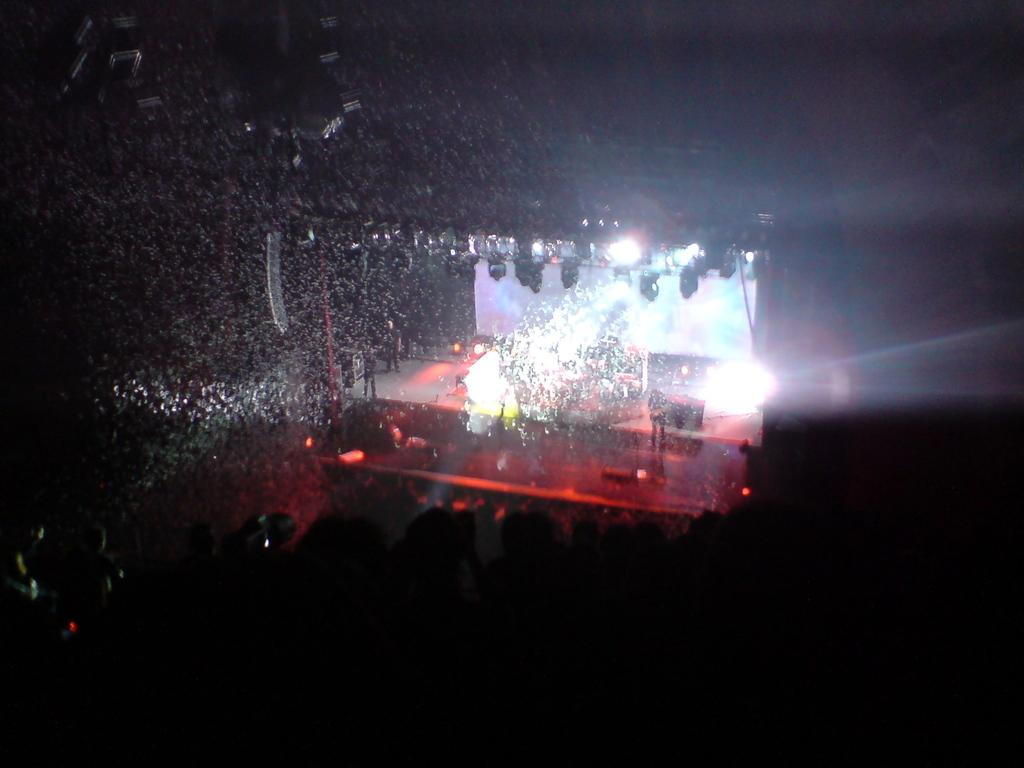What is the main feature in the center of the image? There is a stage in the center of the image. What can be seen illuminating the stage? There are spotlights in the image. What type of equipment is present on the stage? There are musical instruments in the image. Where are the people located in the image? The people are on the left side of the image. What year is depicted on the map in the image? There is no map present in the image, so it is not possible to determine the year depicted. 